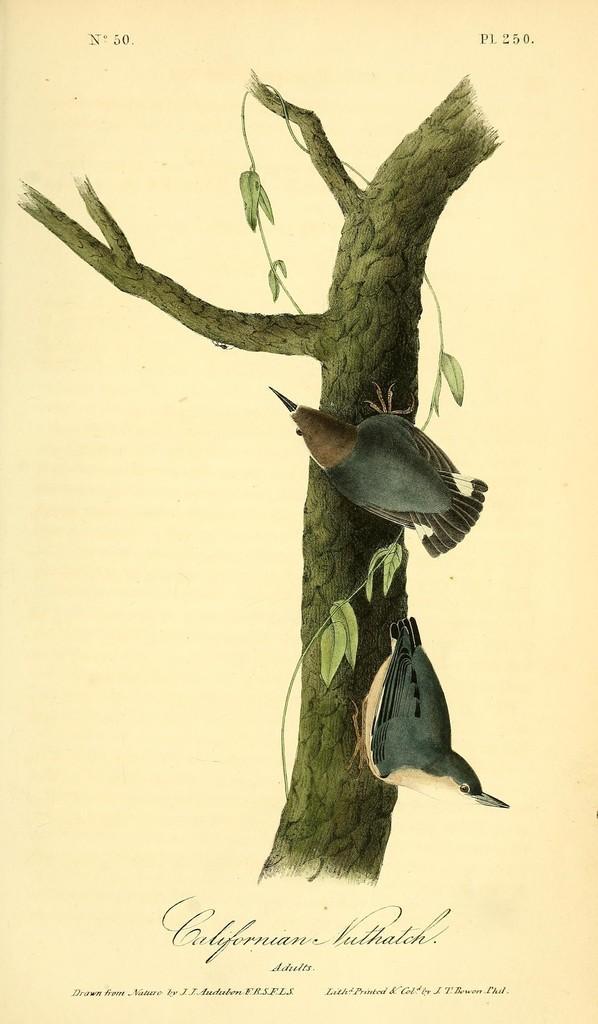In one or two sentences, can you explain what this image depicts? It is a poster. In this image there are two birds on the tree and there is text on the image. 